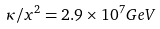Convert formula to latex. <formula><loc_0><loc_0><loc_500><loc_500>\kappa / x ^ { 2 } = 2 . 9 \times 1 0 ^ { 7 } G e V</formula> 